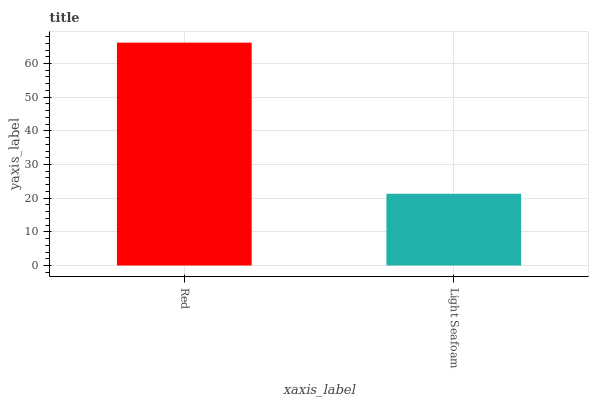Is Light Seafoam the minimum?
Answer yes or no. Yes. Is Red the maximum?
Answer yes or no. Yes. Is Light Seafoam the maximum?
Answer yes or no. No. Is Red greater than Light Seafoam?
Answer yes or no. Yes. Is Light Seafoam less than Red?
Answer yes or no. Yes. Is Light Seafoam greater than Red?
Answer yes or no. No. Is Red less than Light Seafoam?
Answer yes or no. No. Is Red the high median?
Answer yes or no. Yes. Is Light Seafoam the low median?
Answer yes or no. Yes. Is Light Seafoam the high median?
Answer yes or no. No. Is Red the low median?
Answer yes or no. No. 